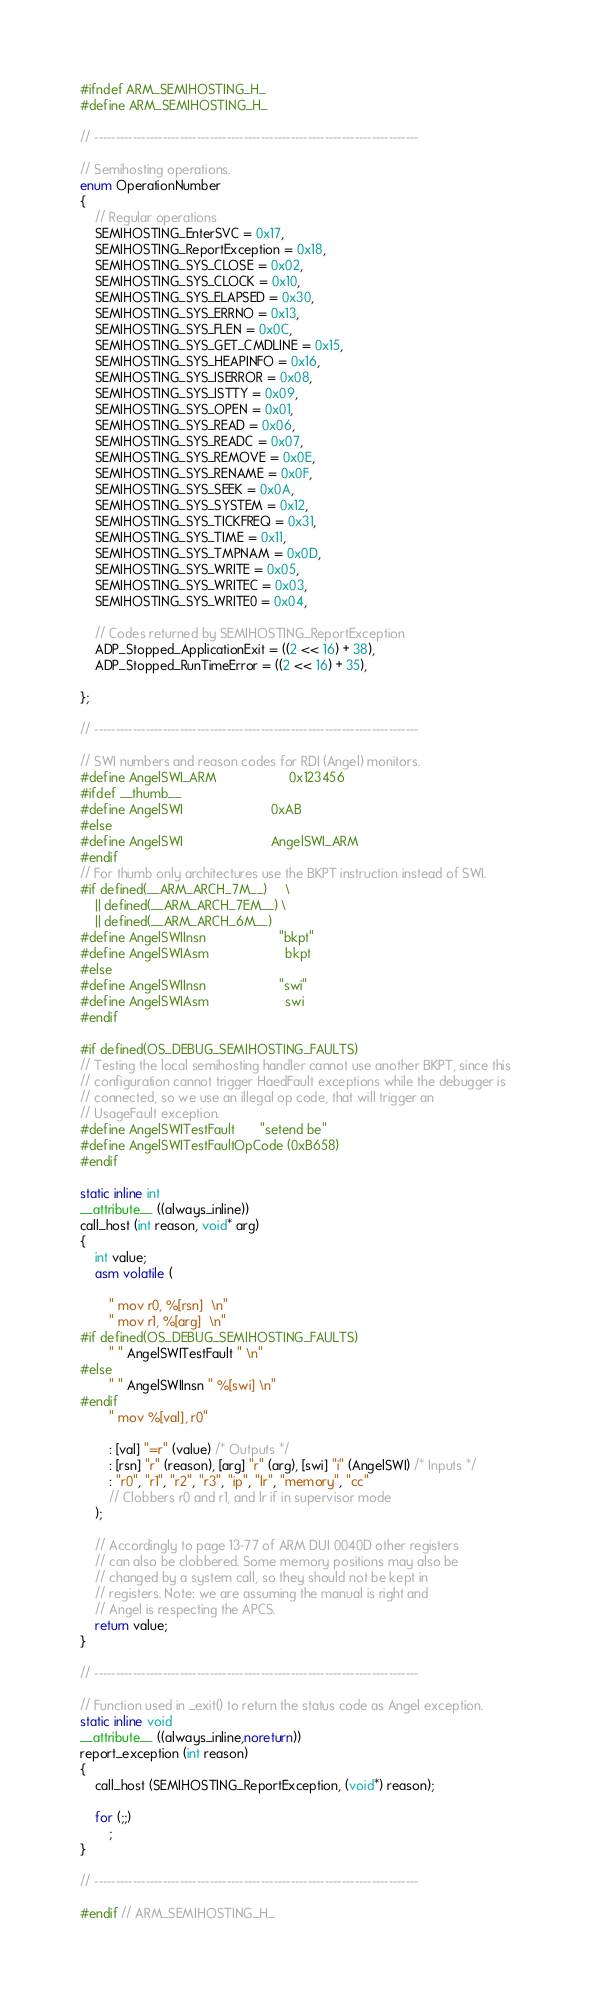<code> <loc_0><loc_0><loc_500><loc_500><_C_>
#ifndef ARM_SEMIHOSTING_H_
#define ARM_SEMIHOSTING_H_

// ----------------------------------------------------------------------------

// Semihosting operations.
enum OperationNumber
{
    // Regular operations
    SEMIHOSTING_EnterSVC = 0x17,
    SEMIHOSTING_ReportException = 0x18,
    SEMIHOSTING_SYS_CLOSE = 0x02,
    SEMIHOSTING_SYS_CLOCK = 0x10,
    SEMIHOSTING_SYS_ELAPSED = 0x30,
    SEMIHOSTING_SYS_ERRNO = 0x13,
    SEMIHOSTING_SYS_FLEN = 0x0C,
    SEMIHOSTING_SYS_GET_CMDLINE = 0x15,
    SEMIHOSTING_SYS_HEAPINFO = 0x16,
    SEMIHOSTING_SYS_ISERROR = 0x08,
    SEMIHOSTING_SYS_ISTTY = 0x09,
    SEMIHOSTING_SYS_OPEN = 0x01,
    SEMIHOSTING_SYS_READ = 0x06,
    SEMIHOSTING_SYS_READC = 0x07,
    SEMIHOSTING_SYS_REMOVE = 0x0E,
    SEMIHOSTING_SYS_RENAME = 0x0F,
    SEMIHOSTING_SYS_SEEK = 0x0A,
    SEMIHOSTING_SYS_SYSTEM = 0x12,
    SEMIHOSTING_SYS_TICKFREQ = 0x31,
    SEMIHOSTING_SYS_TIME = 0x11,
    SEMIHOSTING_SYS_TMPNAM = 0x0D,
    SEMIHOSTING_SYS_WRITE = 0x05,
    SEMIHOSTING_SYS_WRITEC = 0x03,
    SEMIHOSTING_SYS_WRITE0 = 0x04,

    // Codes returned by SEMIHOSTING_ReportException
    ADP_Stopped_ApplicationExit = ((2 << 16) + 38),
    ADP_Stopped_RunTimeError = ((2 << 16) + 35),

};

// ----------------------------------------------------------------------------

// SWI numbers and reason codes for RDI (Angel) monitors.
#define AngelSWI_ARM                    0x123456
#ifdef __thumb__
#define AngelSWI                        0xAB
#else
#define AngelSWI                        AngelSWI_ARM
#endif
// For thumb only architectures use the BKPT instruction instead of SWI.
#if defined(__ARM_ARCH_7M__)     \
    || defined(__ARM_ARCH_7EM__) \
    || defined(__ARM_ARCH_6M__)
#define AngelSWIInsn                    "bkpt"
#define AngelSWIAsm                     bkpt
#else
#define AngelSWIInsn                    "swi"
#define AngelSWIAsm                     swi
#endif

#if defined(OS_DEBUG_SEMIHOSTING_FAULTS)
// Testing the local semihosting handler cannot use another BKPT, since this
// configuration cannot trigger HaedFault exceptions while the debugger is
// connected, so we use an illegal op code, that will trigger an
// UsageFault exception.
#define AngelSWITestFault       "setend be"
#define AngelSWITestFaultOpCode (0xB658)
#endif

static inline int
__attribute__ ((always_inline))
call_host (int reason, void* arg)
{
    int value;
    asm volatile (

        " mov r0, %[rsn]  \n"
        " mov r1, %[arg]  \n"
#if defined(OS_DEBUG_SEMIHOSTING_FAULTS)
        " " AngelSWITestFault " \n"
#else
        " " AngelSWIInsn " %[swi] \n"
#endif
        " mov %[val], r0"

        : [val] "=r" (value) /* Outputs */
        : [rsn] "r" (reason), [arg] "r" (arg), [swi] "i" (AngelSWI) /* Inputs */
        : "r0", "r1", "r2", "r3", "ip", "lr", "memory", "cc"
        // Clobbers r0 and r1, and lr if in supervisor mode
    );

    // Accordingly to page 13-77 of ARM DUI 0040D other registers
    // can also be clobbered. Some memory positions may also be
    // changed by a system call, so they should not be kept in
    // registers. Note: we are assuming the manual is right and
    // Angel is respecting the APCS.
    return value;
}

// ----------------------------------------------------------------------------

// Function used in _exit() to return the status code as Angel exception.
static inline void
__attribute__ ((always_inline,noreturn))
report_exception (int reason)
{
    call_host (SEMIHOSTING_ReportException, (void*) reason);

    for (;;)
        ;
}

// ----------------------------------------------------------------------------

#endif // ARM_SEMIHOSTING_H_
</code> 